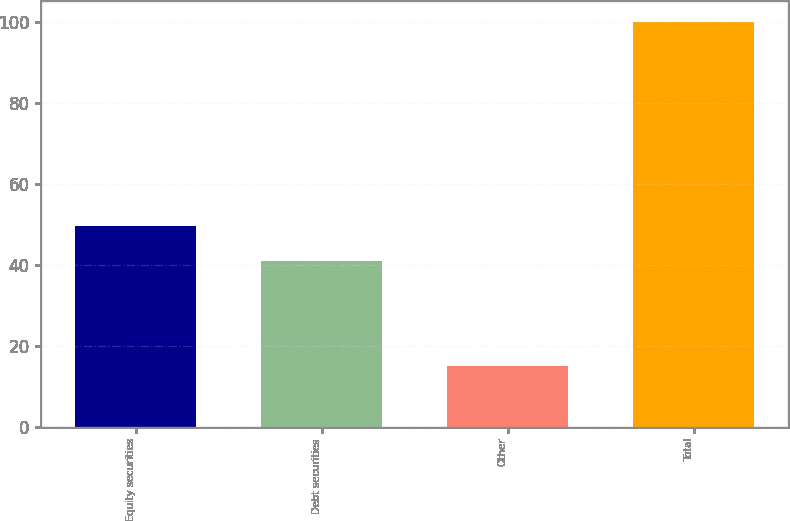Convert chart to OTSL. <chart><loc_0><loc_0><loc_500><loc_500><bar_chart><fcel>Equity securities<fcel>Debt securities<fcel>Other<fcel>Total<nl><fcel>49.5<fcel>41<fcel>15<fcel>100<nl></chart> 